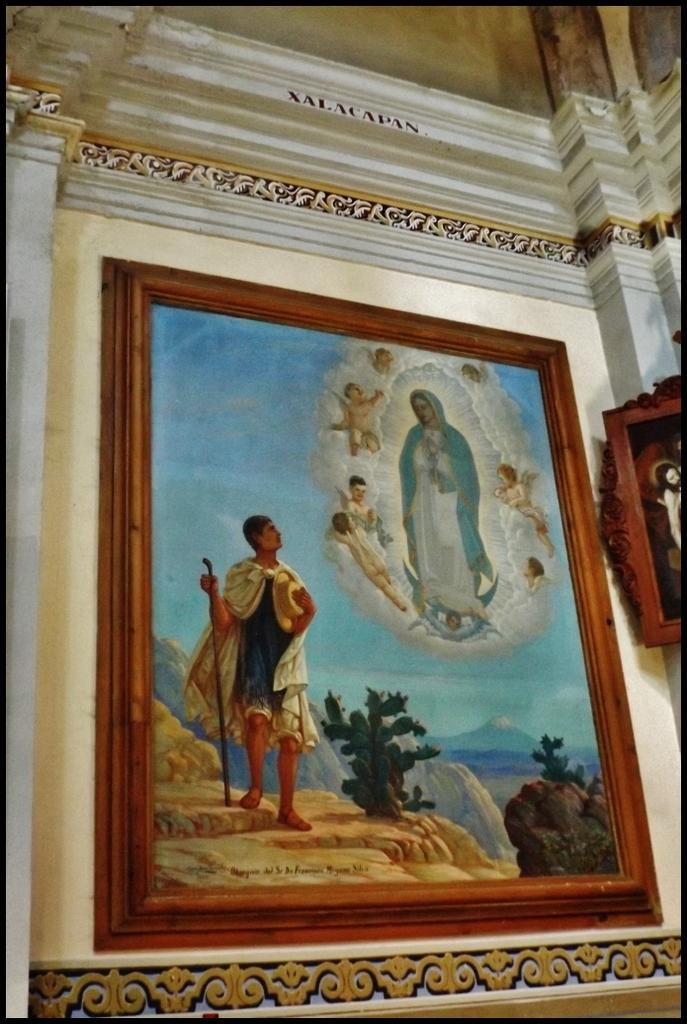What is on the wall in the image? There is a frame on the wall in the image. What type of machine is visible on the shelf in the image? There is no shelf or machine present in the image; it only features a frame on the wall. 